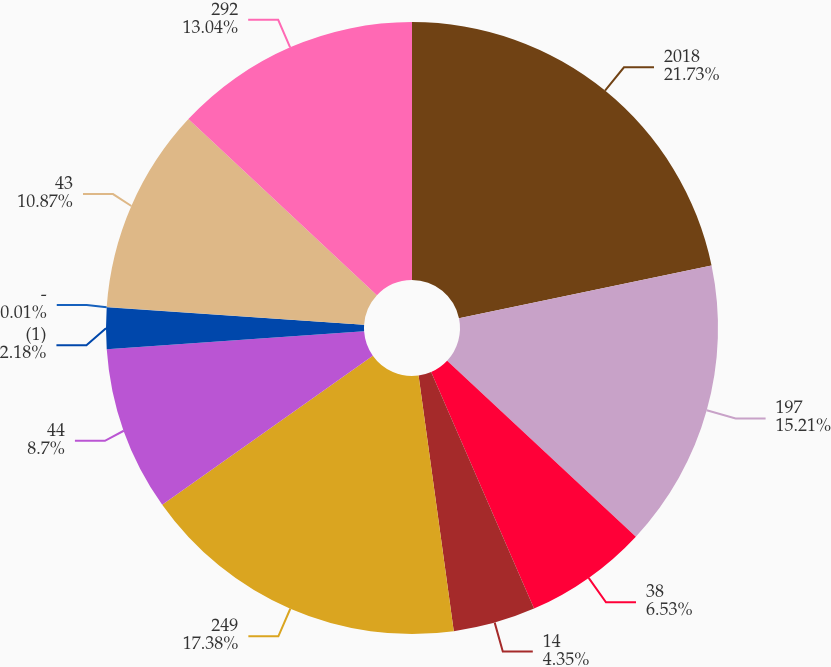Convert chart. <chart><loc_0><loc_0><loc_500><loc_500><pie_chart><fcel>2018<fcel>197<fcel>38<fcel>14<fcel>249<fcel>44<fcel>(1)<fcel>-<fcel>43<fcel>292<nl><fcel>21.73%<fcel>15.21%<fcel>6.53%<fcel>4.35%<fcel>17.38%<fcel>8.7%<fcel>2.18%<fcel>0.01%<fcel>10.87%<fcel>13.04%<nl></chart> 